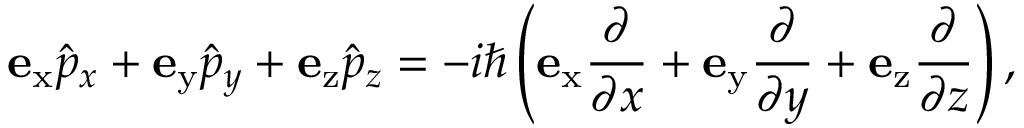<formula> <loc_0><loc_0><loc_500><loc_500>e _ { x } { \hat { p } } _ { x } + e _ { y } { \hat { p } } _ { y } + e _ { z } { \hat { p } } _ { z } = - i \hbar { \left } ( e _ { x } { \frac { \partial } { \partial x } } + e _ { y } { \frac { \partial } { \partial y } } + e _ { z } { \frac { \partial } { \partial z } } \right ) ,</formula> 